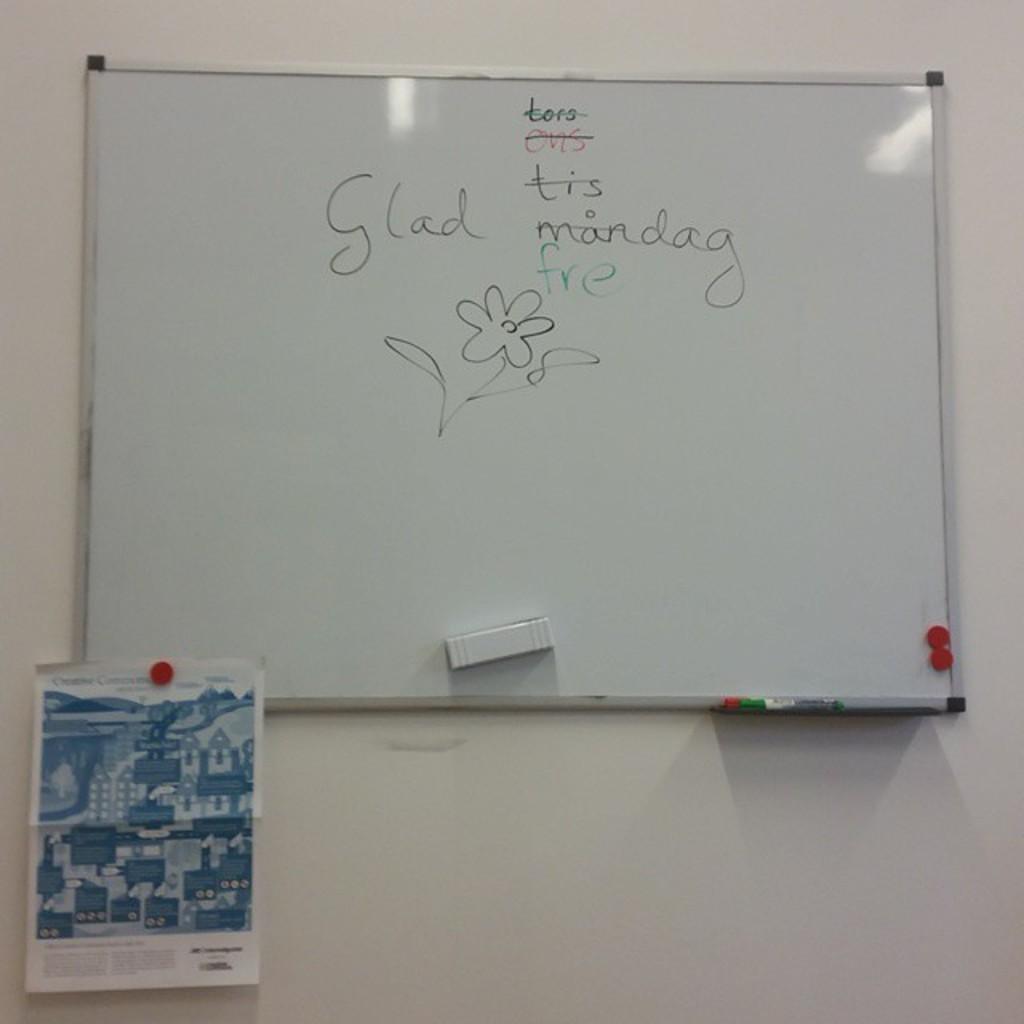Can you be able to understand the writing?
Keep it short and to the point. Yes. What is the word over to the left of the list by itself?
Make the answer very short. Glad. 